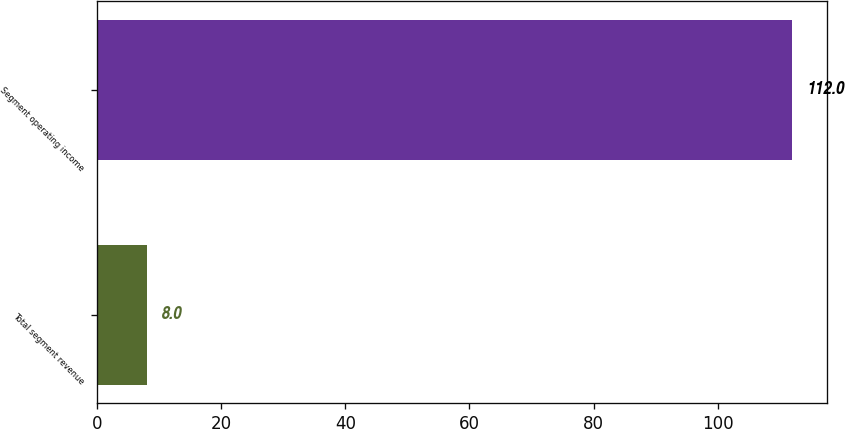Convert chart to OTSL. <chart><loc_0><loc_0><loc_500><loc_500><bar_chart><fcel>Total segment revenue<fcel>Segment operating income<nl><fcel>8<fcel>112<nl></chart> 